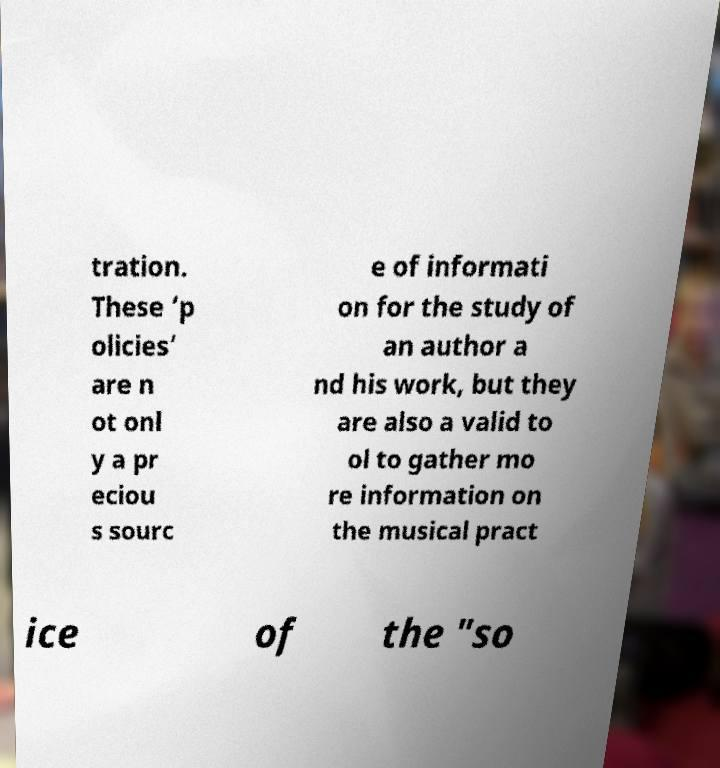What messages or text are displayed in this image? I need them in a readable, typed format. tration. These ‘p olicies’ are n ot onl y a pr eciou s sourc e of informati on for the study of an author a nd his work, but they are also a valid to ol to gather mo re information on the musical pract ice of the "so 